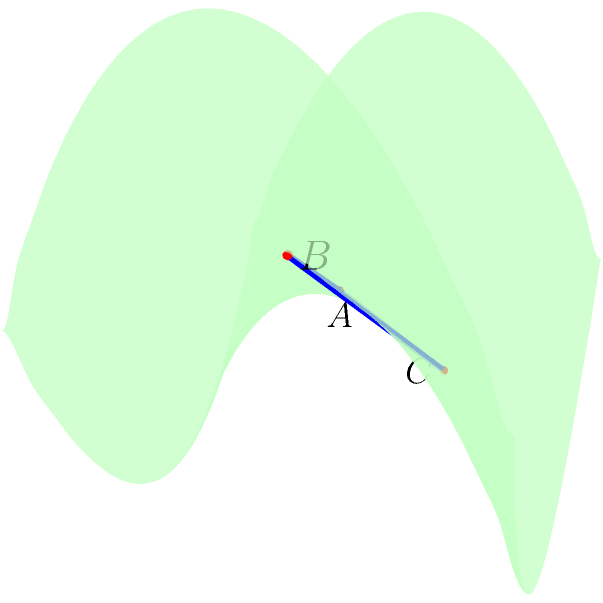Consider a saddle-shaped surface described by the equation $z = 0.5(x^2 - y^2)$. A triangle ABC is drawn on this surface with vertices at A(0,0,0), B(1,0,0.5), and C(0,1,-0.5). If the area of this triangle on a flat surface would be 0.5 square units, what is its approximate area on the saddle surface? (Round your answer to two decimal places) To solve this problem, we need to consider the following steps:

1) In Euclidean geometry, the area of the triangle would indeed be 0.5 square units, as it forms a right-angled triangle with base and height of 1 unit each.

2) However, on a non-Euclidean surface like this saddle, we need to account for the curvature. The area will be different due to the stretching or compression of the surface.

3) To calculate the area on the curved surface, we need to use the concept of the "metric tensor". This tensor describes how distances and areas are distorted on the curved surface.

4) For a surface described by $z = f(x,y)$, the metric tensor is given by:

   $$g = \begin{pmatrix} 
   1 + (\frac{\partial f}{\partial x})^2 & \frac{\partial f}{\partial x}\frac{\partial f}{\partial y} \\
   \frac{\partial f}{\partial x}\frac{\partial f}{\partial y} & 1 + (\frac{\partial f}{\partial y})^2
   \end{pmatrix}$$

5) In our case, $f(x,y) = 0.5(x^2 - y^2)$, so:
   
   $\frac{\partial f}{\partial x} = x$ and $\frac{\partial f}{\partial y} = -y$

6) Substituting into the metric tensor:

   $$g = \begin{pmatrix} 
   1 + x^2 & -xy \\
   -xy & 1 + y^2
   \end{pmatrix}$$

7) The area element on the curved surface is given by $\sqrt{det(g)} dx dy$, where $det(g)$ is the determinant of the metric tensor.

8) $det(g) = (1+x^2)(1+y^2) - (-xy)^2 = 1 + x^2 + y^2 + x^2y^2 + x^2y^2 = 1 + x^2 + y^2 + 2x^2y^2$

9) To get the exact area, we would need to integrate $\sqrt{1 + x^2 + y^2 + 2x^2y^2}$ over the triangle. This is a complex integral.

10) As an approximation, we can evaluate this at the centroid of the triangle (1/3, 1/3) and multiply by the flat area:

    $Area_{curved} \approx 0.5 * \sqrt{1 + (1/3)^2 + (1/3)^2 + 2(1/3)^2(1/3)^2} \approx 0.54$

Therefore, the approximate area of the triangle on the saddle surface is 0.54 square units.
Answer: 0.54 square units 